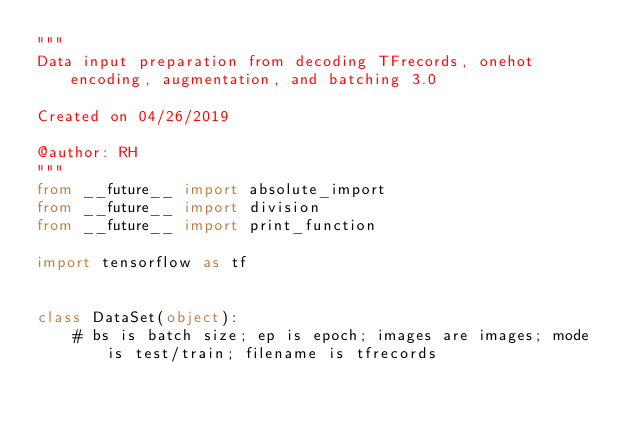Convert code to text. <code><loc_0><loc_0><loc_500><loc_500><_Python_>"""
Data input preparation from decoding TFrecords, onehot encoding, augmentation, and batching 3.0

Created on 04/26/2019

@author: RH
"""
from __future__ import absolute_import
from __future__ import division
from __future__ import print_function

import tensorflow as tf


class DataSet(object):
    # bs is batch size; ep is epoch; images are images; mode is test/train; filename is tfrecords</code> 